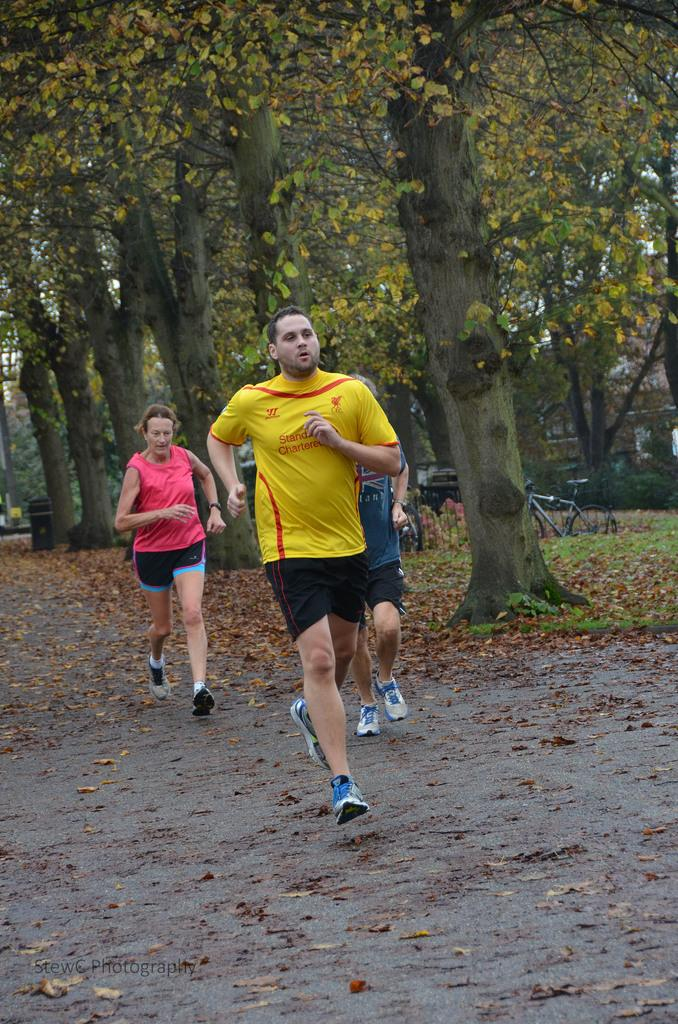How many people are in the image? There are three persons in the image. Where are the persons located in the image? The persons are on a path in the image. What can be seen in the background of the image? There are lots of trees and a cycle visible in the background of the image. What type of machine is being used by the lawyer in the image? There is no machine or lawyer present in the image. 